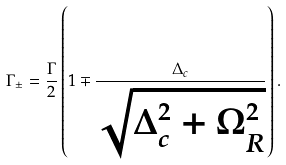Convert formula to latex. <formula><loc_0><loc_0><loc_500><loc_500>\Gamma _ { \pm } = \frac { \Gamma } { 2 } \left ( 1 \mp \frac { \Delta _ { c } } { \sqrt { \Delta _ { c } ^ { 2 } + \Omega _ { R } ^ { 2 } } } \right ) .</formula> 